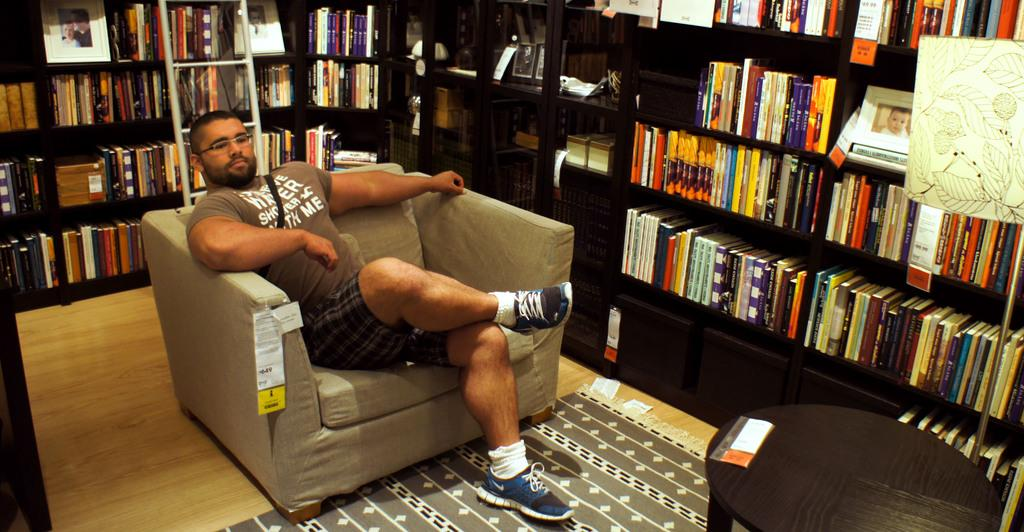Where was the image taken? The image was taken in a room. What can be found in the room? The room is filled with books. What piece of furniture is in the center of the room? There is a sofa in the center of the room. Who is sitting on the sofa? A person is sitting on the sofa. Where is the table located in the room? There is a table in the right bottom of the room. How many babies are crawling on the floor in the image? There are no babies present in the image; it only shows a room filled with books, a sofa, a person sitting on the sofa, and a table. What type of drum can be seen in the image? There is no drum present in the image. 